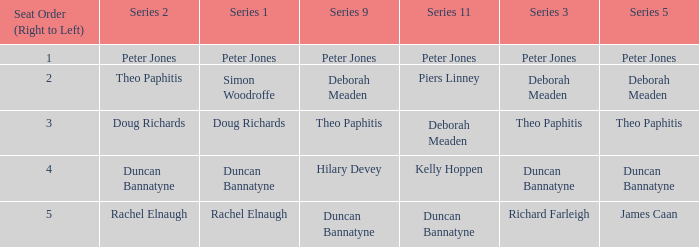Which Series 2 has a Series 3 of deborah meaden? Theo Paphitis. 